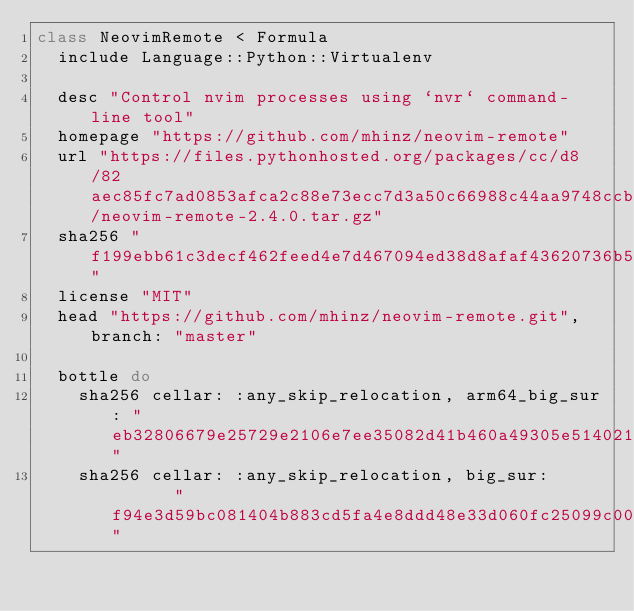Convert code to text. <code><loc_0><loc_0><loc_500><loc_500><_Ruby_>class NeovimRemote < Formula
  include Language::Python::Virtualenv

  desc "Control nvim processes using `nvr` command-line tool"
  homepage "https://github.com/mhinz/neovim-remote"
  url "https://files.pythonhosted.org/packages/cc/d8/82aec85fc7ad0853afca2c88e73ecc7d3a50c66988c44aa9748ccbc9b689/neovim-remote-2.4.0.tar.gz"
  sha256 "f199ebb61c3decf462feed4e7d467094ed38d8afaf43620736b5983a12fe2427"
  license "MIT"
  head "https://github.com/mhinz/neovim-remote.git", branch: "master"

  bottle do
    sha256 cellar: :any_skip_relocation, arm64_big_sur: "eb32806679e25729e2106e7ee35082d41b460a49305e51402121a21a013f8924"
    sha256 cellar: :any_skip_relocation, big_sur:       "f94e3d59bc081404b883cd5fa4e8ddd48e33d060fc25099c0070ba52e8ac9682"</code> 